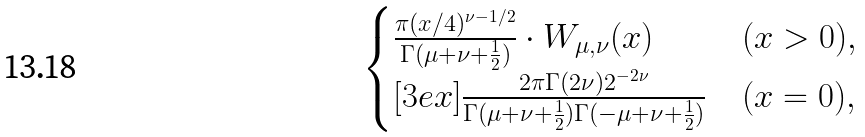Convert formula to latex. <formula><loc_0><loc_0><loc_500><loc_500>\begin{cases} \frac { \pi ( x / 4 ) ^ { \nu - 1 / 2 } } { \Gamma ( \mu + \nu + \frac { 1 } { 2 } ) } \cdot W _ { \mu , \nu } ( x ) & ( x > 0 ) , \\ [ 3 e x ] \frac { 2 \pi \Gamma ( 2 \nu ) 2 ^ { - 2 \nu } } { \Gamma ( \mu + \nu + \frac { 1 } { 2 } ) \Gamma ( - \mu + \nu + \frac { 1 } { 2 } ) } & ( x = 0 ) , \end{cases}</formula> 